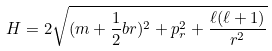<formula> <loc_0><loc_0><loc_500><loc_500>H = 2 \sqrt { ( m + \frac { 1 } { 2 } b r ) ^ { 2 } + p ^ { 2 } _ { r } + \frac { \ell ( \ell + 1 ) } { r ^ { 2 } } }</formula> 